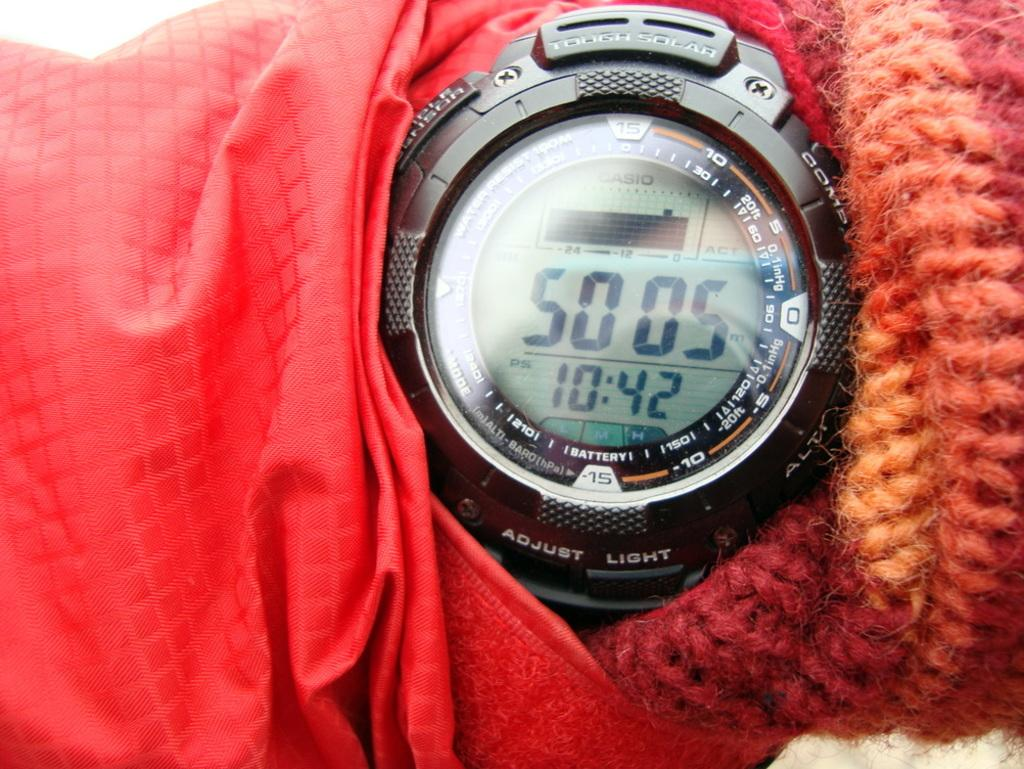<image>
Create a compact narrative representing the image presented. A digital watch says 5005 and that the time is 10:42. 